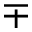<formula> <loc_0><loc_0><loc_500><loc_500>\mp</formula> 